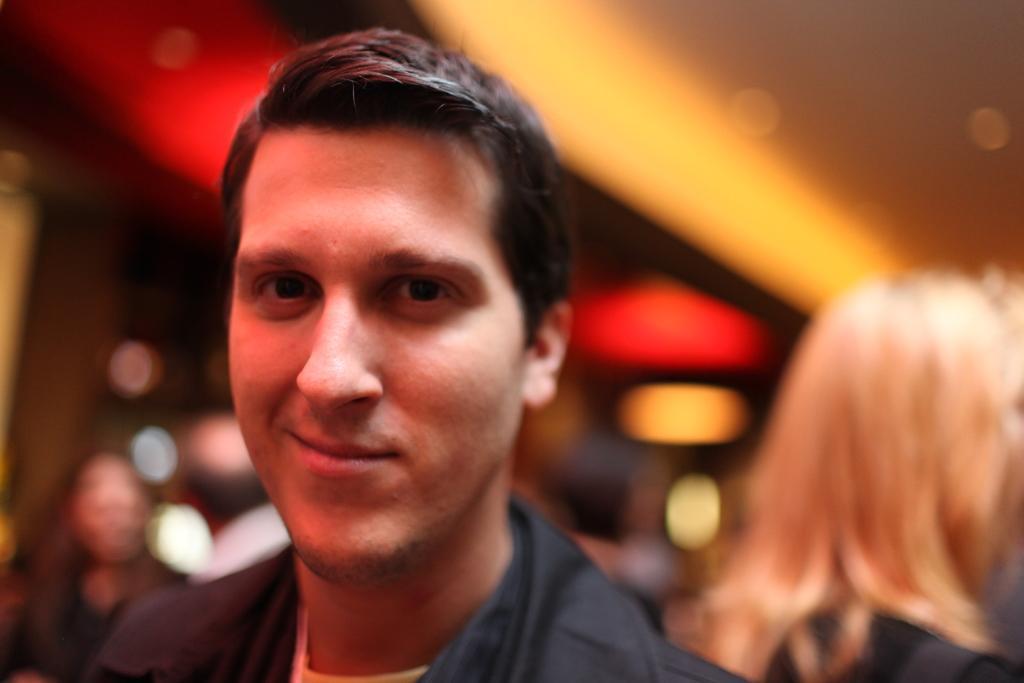Could you give a brief overview of what you see in this image? In this image I can see a person wearing black color dress is smiling. I can see the blurry background in which I can see few persons. 